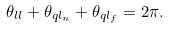<formula> <loc_0><loc_0><loc_500><loc_500>\theta _ { l l } + \theta _ { q l _ { n } } + \theta _ { q l _ { f } } = 2 \pi .</formula> 